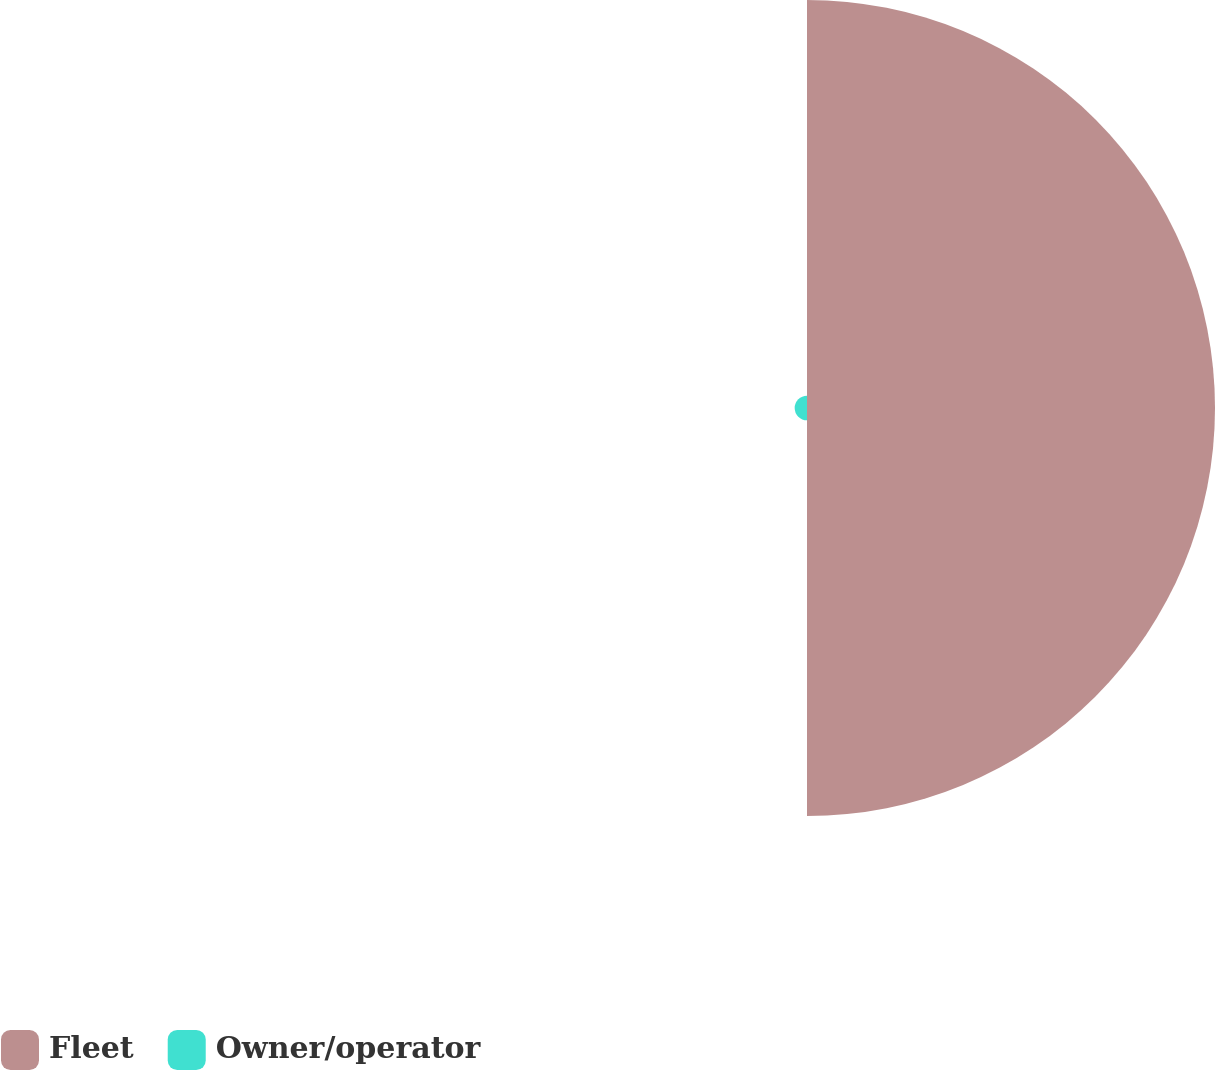Convert chart to OTSL. <chart><loc_0><loc_0><loc_500><loc_500><pie_chart><fcel>Fleet<fcel>Owner/operator<nl><fcel>97.07%<fcel>2.93%<nl></chart> 